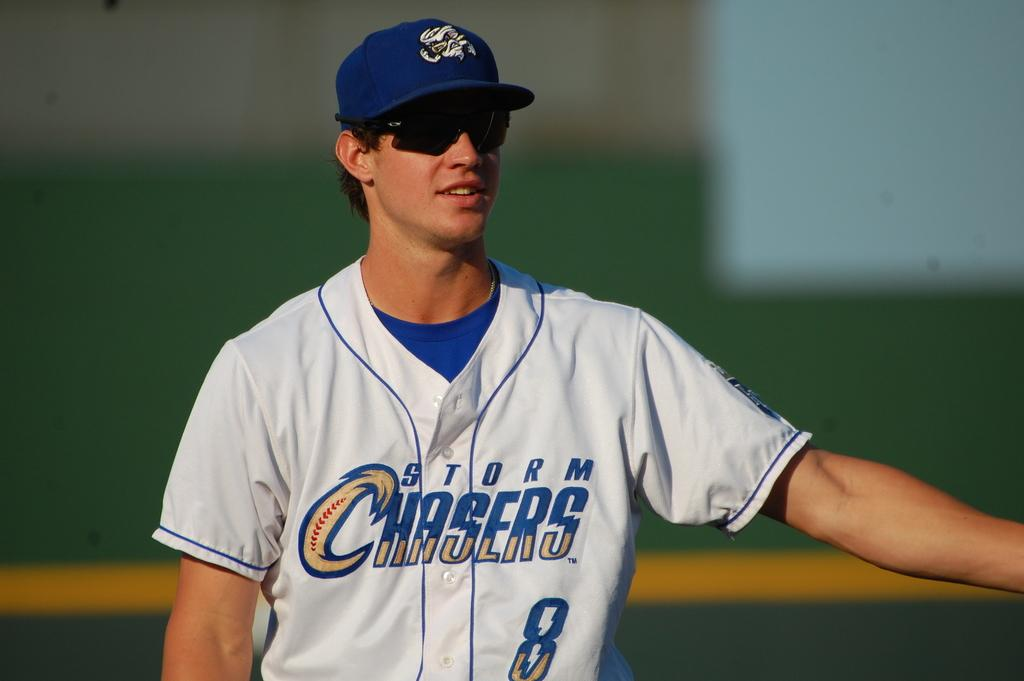Provide a one-sentence caption for the provided image. A Storm Chasers baseball player in on-field wearing sun glasses. 